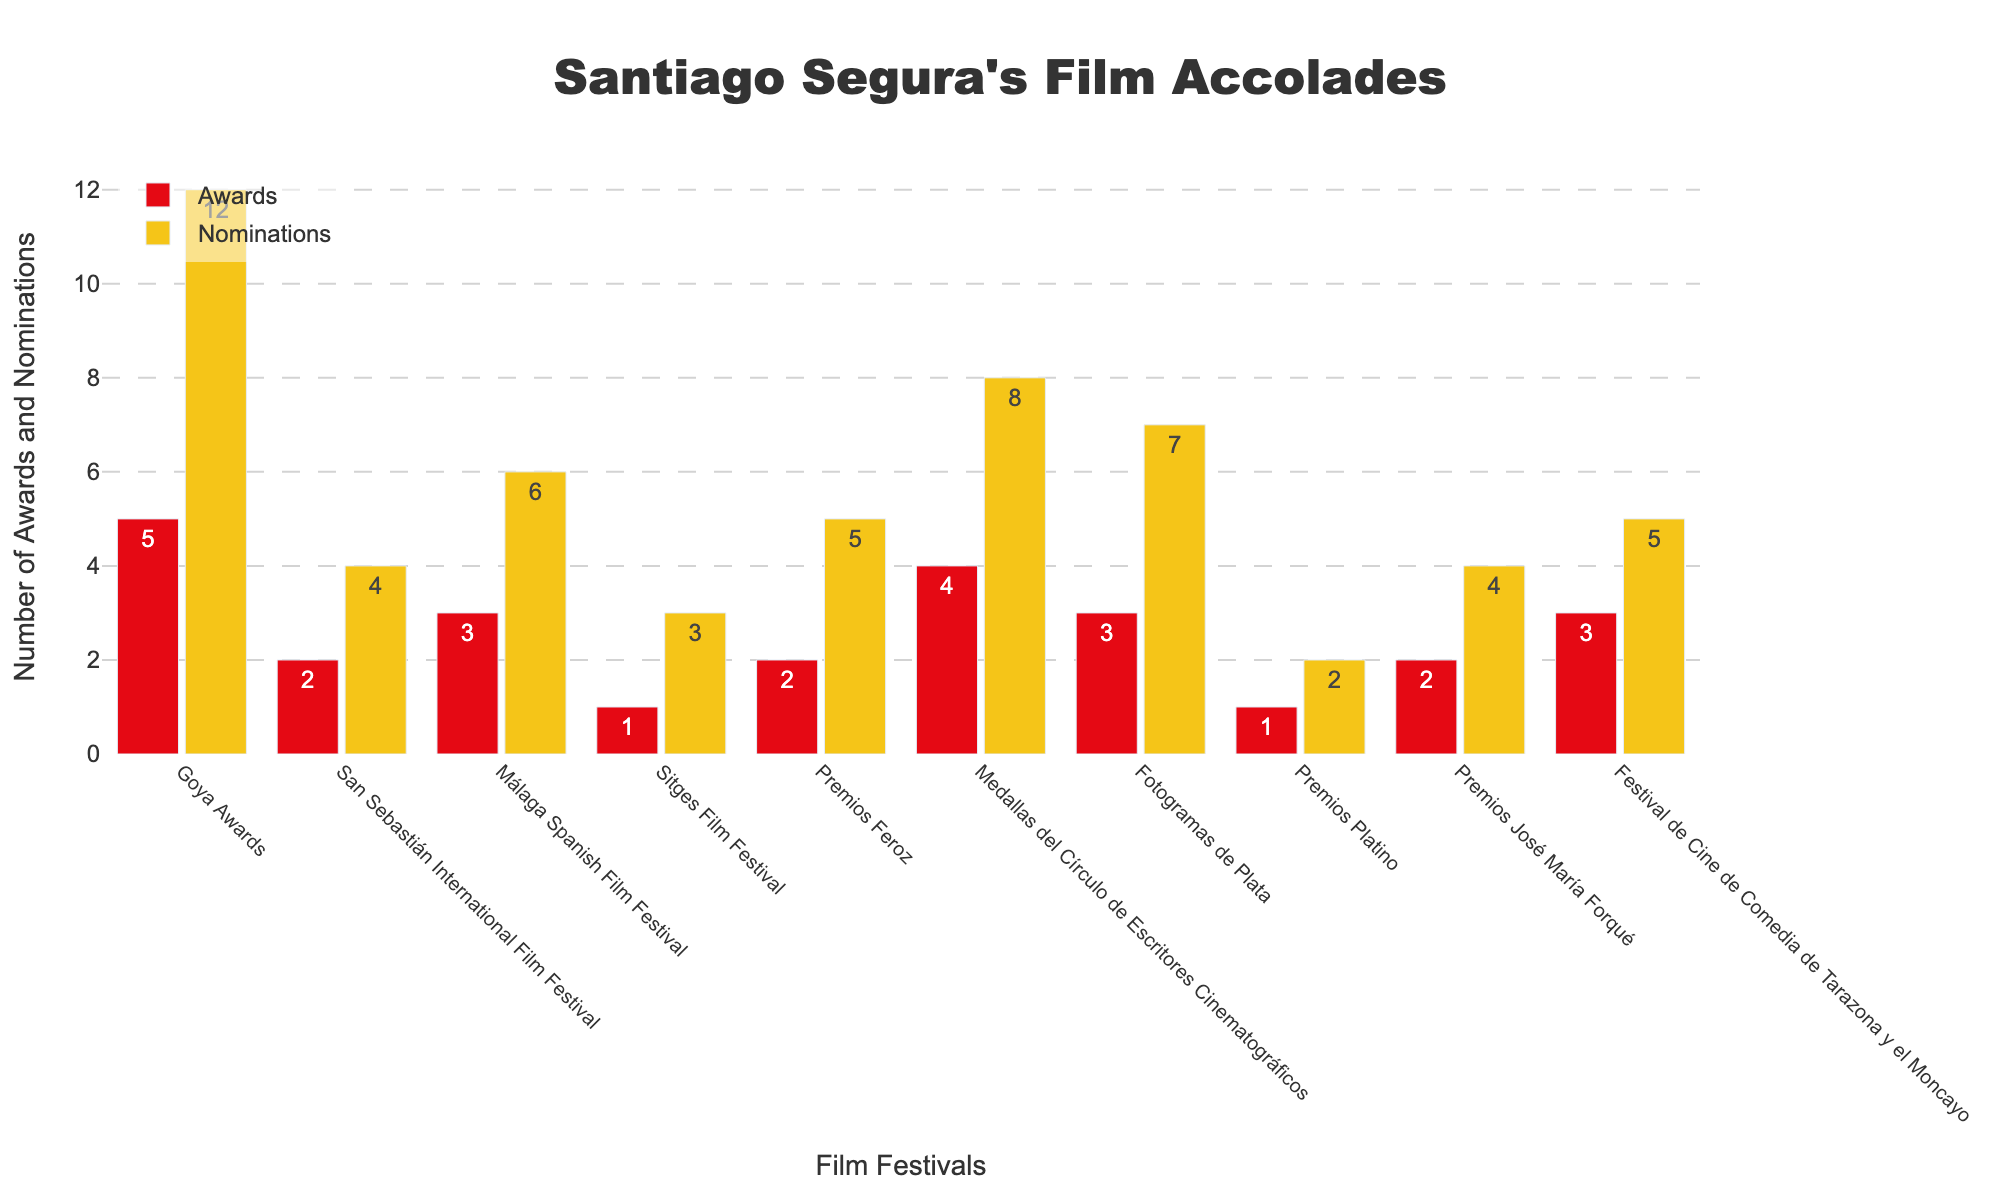Which festival has the highest number of awards received by Santiago Segura's films? By referring to the bar chart, the Goya Awards bar representing awards is the tallest among those representing awards from all the festivals.
Answer: Goya Awards How many total nominations did Santiago Segura's films receive across the San Sebastián International Film Festival and Sitges Film Festival? Add the nominations from both festivals: 4 (San Sebastián) + 3 (Sitges).
Answer: 7 Compare the number of awards and nominations Santiago Segura's films received at the Fotogramas de Plata. Which one is higher? By looking at the bars for Fotogramas de Plata, the nominations bar is taller than the awards bar.
Answer: Nominations Which festival has an equal number of awards and nominations received by Santiago Segura's films? By visually inspecting the bars, the Premios Platino Festival shows equal height bars for awards and nominations (1 each).
Answer: Premios Platino What is the total number of awards received by Santiago Segura's films across all festivals? Sum the values: 5 + 2 + 3 + 1 + 2 + 4 + 3 + 1 + 2 + 3.
Answer: 26 Which festival has the smallest number of nominations, and how many are there? By checking the height of the nominations bars, Premios Platino has the smallest number (2).
Answer: Premios Platino, 2 nominations Calculate the average number of awards won per festival. Sum the awards (26) and divide by the number of festivals (10). The calculation is 26 / 10 = 2.6.
Answer: 2.6 How many more nominations than awards did Santiago Segura's films receive at the Medallas del Círculo de Escritores Cinematográficos? Subtract the number of awards from the number of nominations: 8 (nominations) - 4 (awards).
Answer: 4 What's the difference between the total number of nominations and the total number of awards for Santiago Segura's films? Sum the nominations: 12 + 4 + 6 + 3 + 5 + 8 + 7 + 2 + 4 + 5 = 56. Subtract the total awards (26) from the total nominations (56).
Answer: 30 Which two festivals have the same number of awards, and what is this number? By visually comparing the bars, the Málaga Spanish Film Festival and Fotogramas de Plata  festivals each have 3 awards.
Answer: Málaga Spanish Film Festival and Fotogramas de Plata, 3 awards 